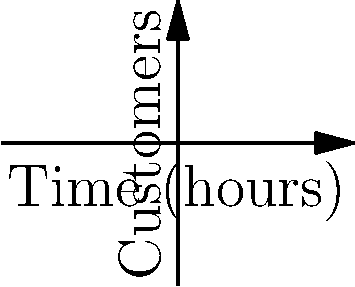The graph shows the number of customers at your sports bar (blue curve) and a nearby food truck (red curve) during a big game. At the 5-hour mark (point A for the bar and point B for the food truck), what is the instantaneous rate of change in the difference between the number of customers at the bar and the food truck? To solve this problem, we need to follow these steps:

1) The difference in customers is represented by $f(x) - g(x)$, where $f(x)$ is the bar's function and $g(x)$ is the food truck's function.

2) We need to find the derivative of this difference at $x = 5$:
   $\frac{d}{dx}(f(x) - g(x)) = f'(x) - g'(x)$

3) From the graph, we can deduce:
   $f(x) = 100 - 0.5x^2$
   $g(x) = 20 + 0.3x^2$

4) Let's calculate the derivatives:
   $f'(x) = -x$
   $g'(x) = 0.6x$

5) Now, we can find the rate of change of the difference:
   $\frac{d}{dx}(f(x) - g(x)) = f'(x) - g'(x) = -x - 0.6x = -1.6x$

6) At $x = 5$:
   $-1.6(5) = -8$

Therefore, at the 5-hour mark, the instantaneous rate of change in the difference between the number of customers at the bar and the food truck is -8 customers per hour.
Answer: $-8$ customers/hour 